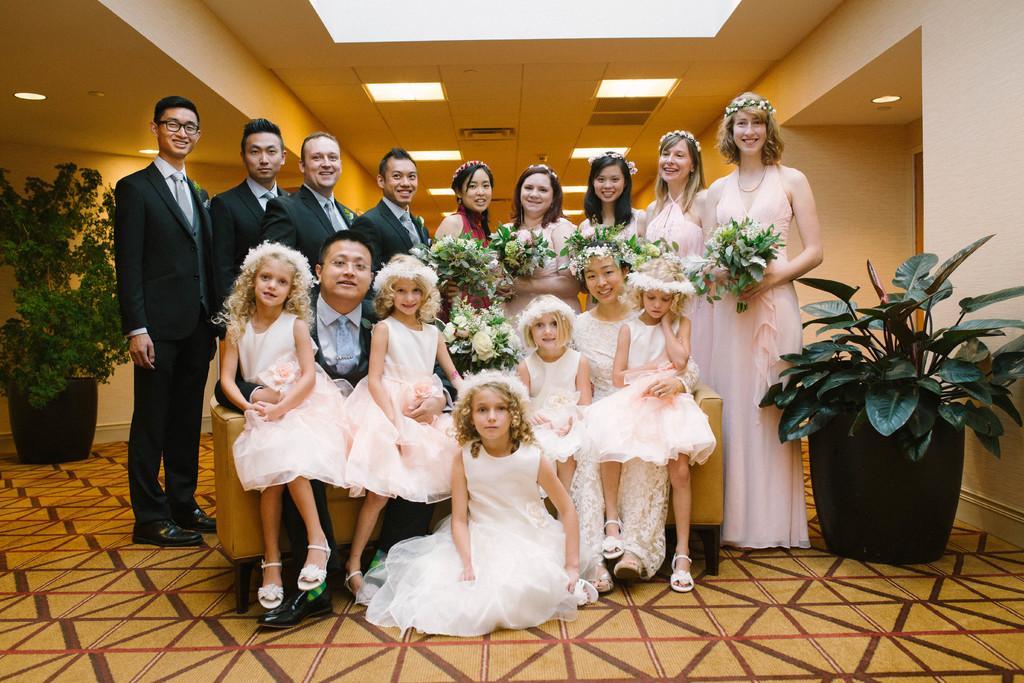Describe this image in one or two sentences. In this image in the center there are a group of people who are standing, and some of them are holding some flower bouquets and there is one couch. On the couch there is one man and one woman who are sitting and they are holding babies, at the bottom there is a floor and on the right side and left side there are two flower pots and plants. And on the top there is ceiling and some lights. 